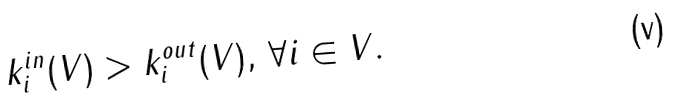<formula> <loc_0><loc_0><loc_500><loc_500>k _ { i } ^ { i n } ( V ) > k _ { i } ^ { o u t } ( V ) , \, \forall i \in V .</formula> 